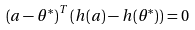<formula> <loc_0><loc_0><loc_500><loc_500>\left ( a - \theta ^ { \ast } \right ) ^ { T } \left ( h ( a ) - h ( \theta ^ { \ast } ) \right ) = 0</formula> 